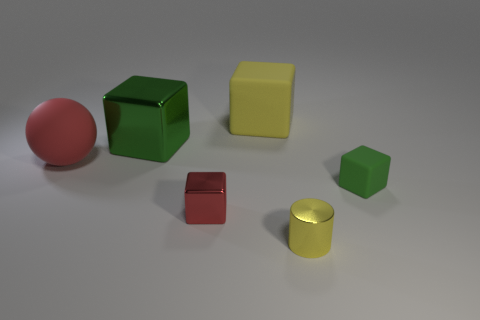Subtract 1 blocks. How many blocks are left? 3 Add 4 large red things. How many objects exist? 10 Subtract all cylinders. How many objects are left? 5 Subtract 0 green balls. How many objects are left? 6 Subtract all big blue things. Subtract all balls. How many objects are left? 5 Add 3 big spheres. How many big spheres are left? 4 Add 5 small blue metal blocks. How many small blue metal blocks exist? 5 